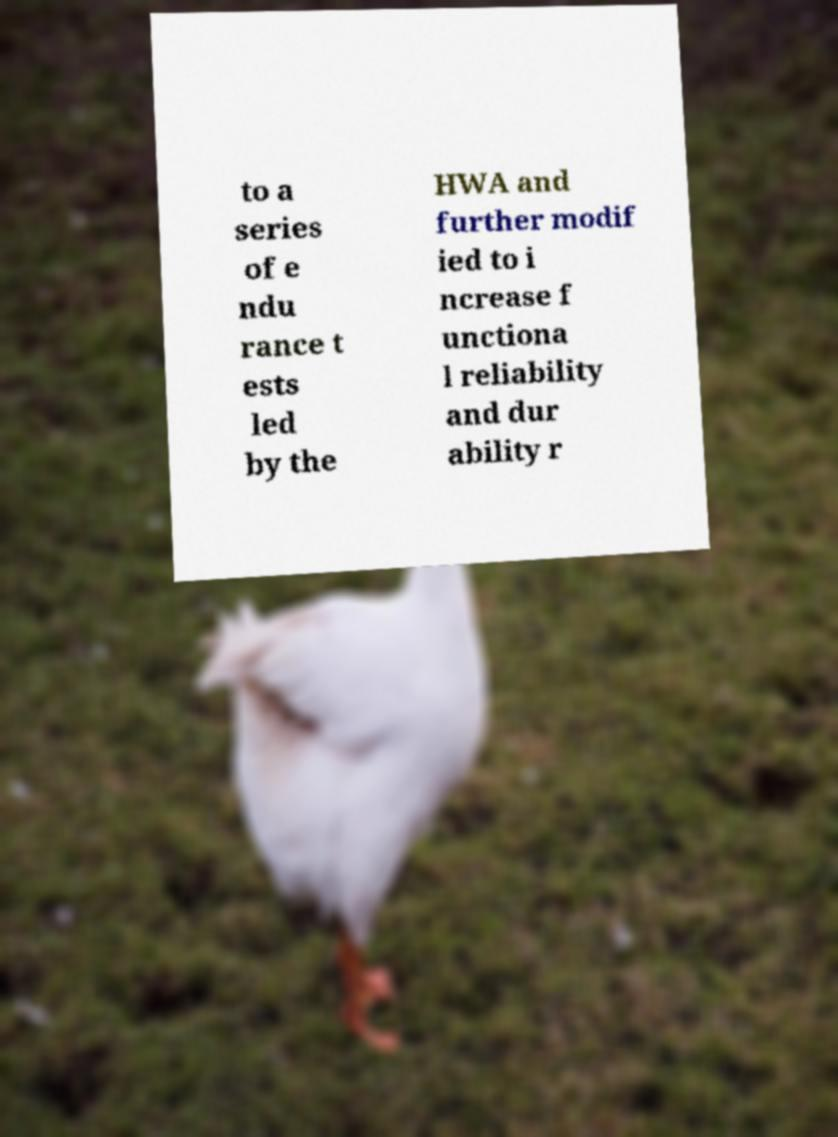For documentation purposes, I need the text within this image transcribed. Could you provide that? to a series of e ndu rance t ests led by the HWA and further modif ied to i ncrease f unctiona l reliability and dur ability r 